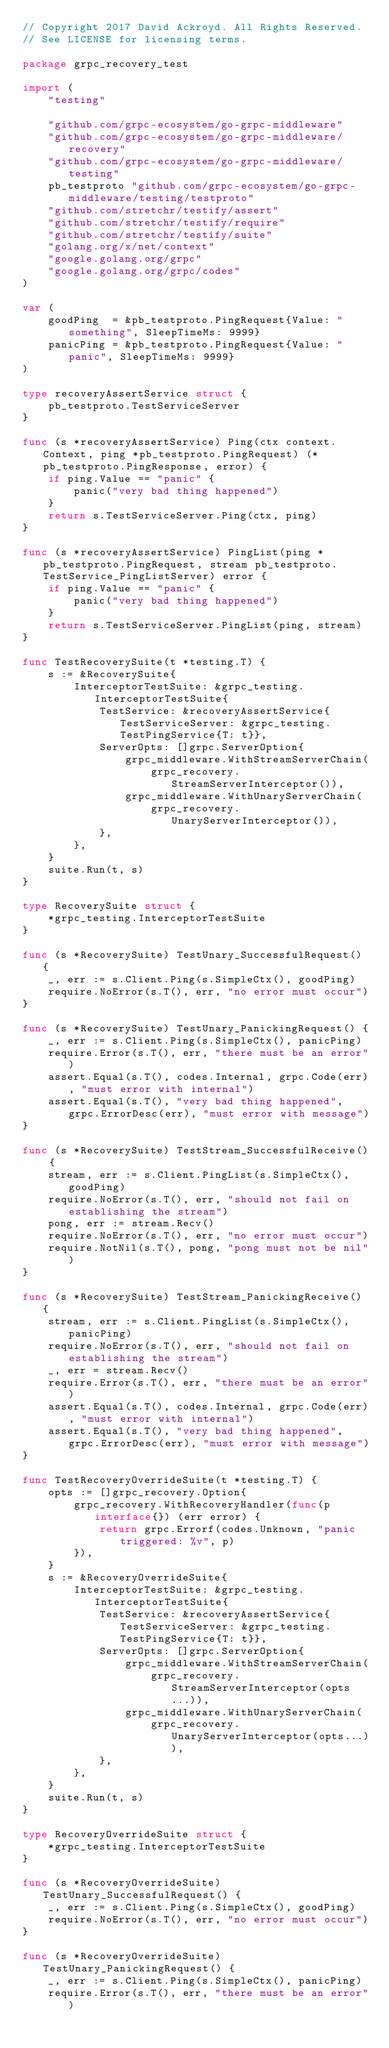<code> <loc_0><loc_0><loc_500><loc_500><_Go_>// Copyright 2017 David Ackroyd. All Rights Reserved.
// See LICENSE for licensing terms.

package grpc_recovery_test

import (
	"testing"

	"github.com/grpc-ecosystem/go-grpc-middleware"
	"github.com/grpc-ecosystem/go-grpc-middleware/recovery"
	"github.com/grpc-ecosystem/go-grpc-middleware/testing"
	pb_testproto "github.com/grpc-ecosystem/go-grpc-middleware/testing/testproto"
	"github.com/stretchr/testify/assert"
	"github.com/stretchr/testify/require"
	"github.com/stretchr/testify/suite"
	"golang.org/x/net/context"
	"google.golang.org/grpc"
	"google.golang.org/grpc/codes"
)

var (
	goodPing  = &pb_testproto.PingRequest{Value: "something", SleepTimeMs: 9999}
	panicPing = &pb_testproto.PingRequest{Value: "panic", SleepTimeMs: 9999}
)

type recoveryAssertService struct {
	pb_testproto.TestServiceServer
}

func (s *recoveryAssertService) Ping(ctx context.Context, ping *pb_testproto.PingRequest) (*pb_testproto.PingResponse, error) {
	if ping.Value == "panic" {
		panic("very bad thing happened")
	}
	return s.TestServiceServer.Ping(ctx, ping)
}

func (s *recoveryAssertService) PingList(ping *pb_testproto.PingRequest, stream pb_testproto.TestService_PingListServer) error {
	if ping.Value == "panic" {
		panic("very bad thing happened")
	}
	return s.TestServiceServer.PingList(ping, stream)
}

func TestRecoverySuite(t *testing.T) {
	s := &RecoverySuite{
		InterceptorTestSuite: &grpc_testing.InterceptorTestSuite{
			TestService: &recoveryAssertService{TestServiceServer: &grpc_testing.TestPingService{T: t}},
			ServerOpts: []grpc.ServerOption{
				grpc_middleware.WithStreamServerChain(
					grpc_recovery.StreamServerInterceptor()),
				grpc_middleware.WithUnaryServerChain(
					grpc_recovery.UnaryServerInterceptor()),
			},
		},
	}
	suite.Run(t, s)
}

type RecoverySuite struct {
	*grpc_testing.InterceptorTestSuite
}

func (s *RecoverySuite) TestUnary_SuccessfulRequest() {
	_, err := s.Client.Ping(s.SimpleCtx(), goodPing)
	require.NoError(s.T(), err, "no error must occur")
}

func (s *RecoverySuite) TestUnary_PanickingRequest() {
	_, err := s.Client.Ping(s.SimpleCtx(), panicPing)
	require.Error(s.T(), err, "there must be an error")
	assert.Equal(s.T(), codes.Internal, grpc.Code(err), "must error with internal")
	assert.Equal(s.T(), "very bad thing happened", grpc.ErrorDesc(err), "must error with message")
}

func (s *RecoverySuite) TestStream_SuccessfulReceive() {
	stream, err := s.Client.PingList(s.SimpleCtx(), goodPing)
	require.NoError(s.T(), err, "should not fail on establishing the stream")
	pong, err := stream.Recv()
	require.NoError(s.T(), err, "no error must occur")
	require.NotNil(s.T(), pong, "pong must not be nil")
}

func (s *RecoverySuite) TestStream_PanickingReceive() {
	stream, err := s.Client.PingList(s.SimpleCtx(), panicPing)
	require.NoError(s.T(), err, "should not fail on establishing the stream")
	_, err = stream.Recv()
	require.Error(s.T(), err, "there must be an error")
	assert.Equal(s.T(), codes.Internal, grpc.Code(err), "must error with internal")
	assert.Equal(s.T(), "very bad thing happened", grpc.ErrorDesc(err), "must error with message")
}

func TestRecoveryOverrideSuite(t *testing.T) {
	opts := []grpc_recovery.Option{
		grpc_recovery.WithRecoveryHandler(func(p interface{}) (err error) {
			return grpc.Errorf(codes.Unknown, "panic triggered: %v", p)
		}),
	}
	s := &RecoveryOverrideSuite{
		InterceptorTestSuite: &grpc_testing.InterceptorTestSuite{
			TestService: &recoveryAssertService{TestServiceServer: &grpc_testing.TestPingService{T: t}},
			ServerOpts: []grpc.ServerOption{
				grpc_middleware.WithStreamServerChain(
					grpc_recovery.StreamServerInterceptor(opts...)),
				grpc_middleware.WithUnaryServerChain(
					grpc_recovery.UnaryServerInterceptor(opts...)),
			},
		},
	}
	suite.Run(t, s)
}

type RecoveryOverrideSuite struct {
	*grpc_testing.InterceptorTestSuite
}

func (s *RecoveryOverrideSuite) TestUnary_SuccessfulRequest() {
	_, err := s.Client.Ping(s.SimpleCtx(), goodPing)
	require.NoError(s.T(), err, "no error must occur")
}

func (s *RecoveryOverrideSuite) TestUnary_PanickingRequest() {
	_, err := s.Client.Ping(s.SimpleCtx(), panicPing)
	require.Error(s.T(), err, "there must be an error")</code> 